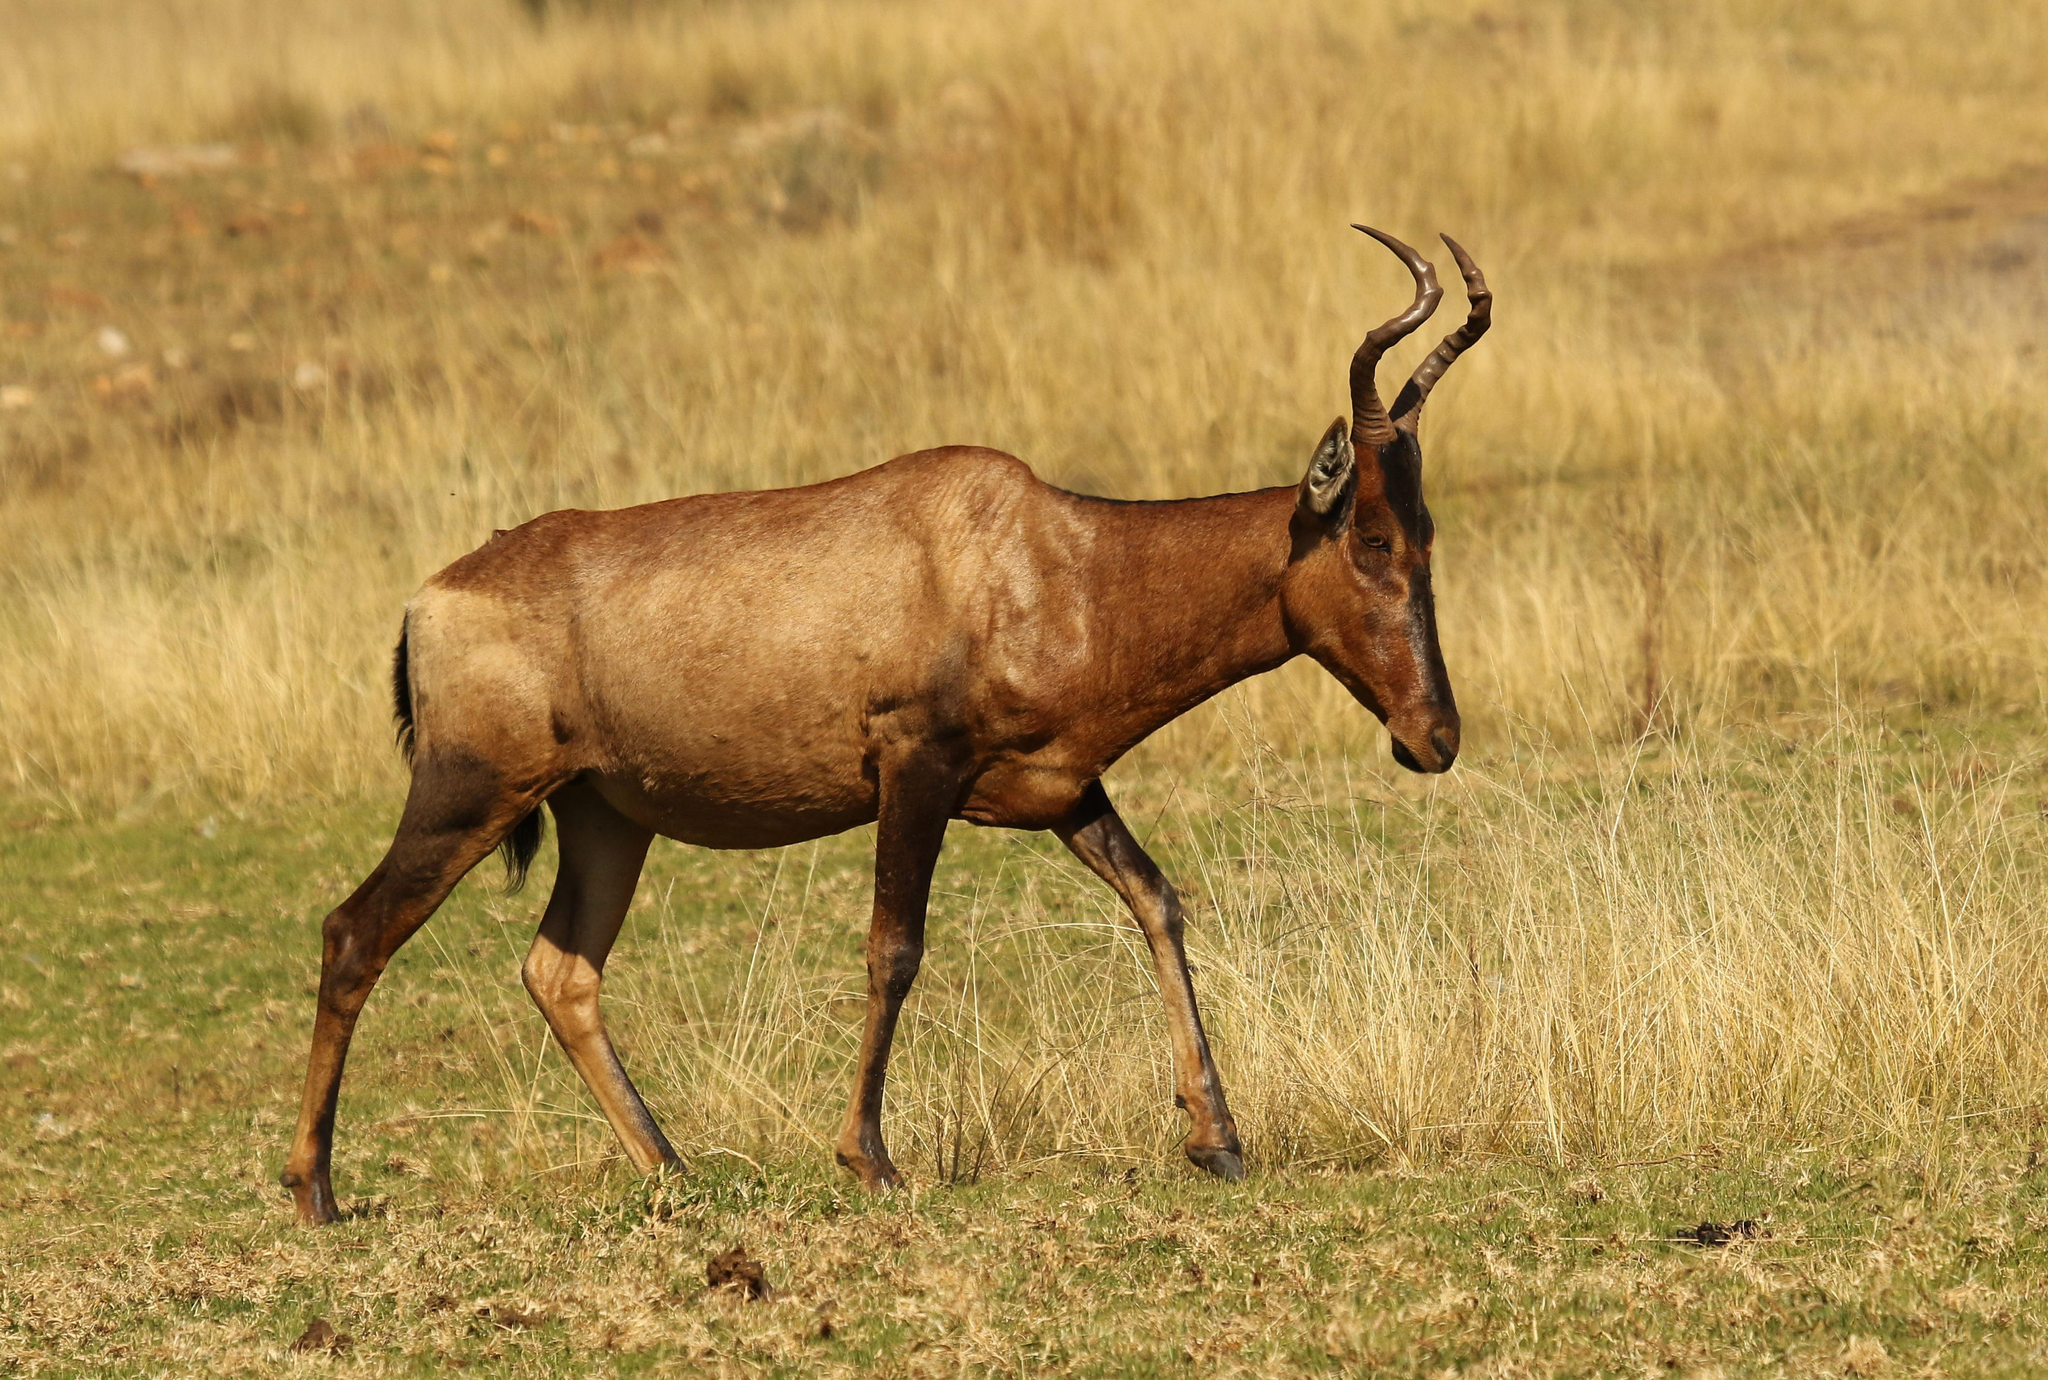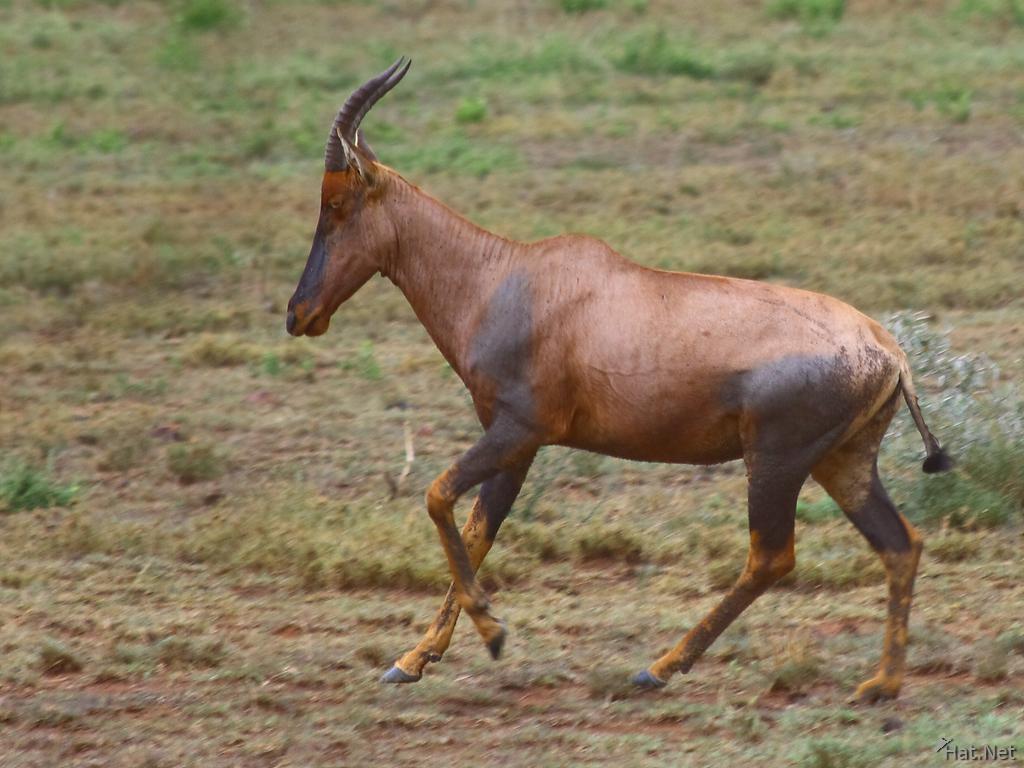The first image is the image on the left, the second image is the image on the right. Examine the images to the left and right. Is the description "The left and right image contains the same number of antelopes." accurate? Answer yes or no. Yes. The first image is the image on the left, the second image is the image on the right. Assess this claim about the two images: "The left image shows an animal facing to the right.". Correct or not? Answer yes or no. Yes. 